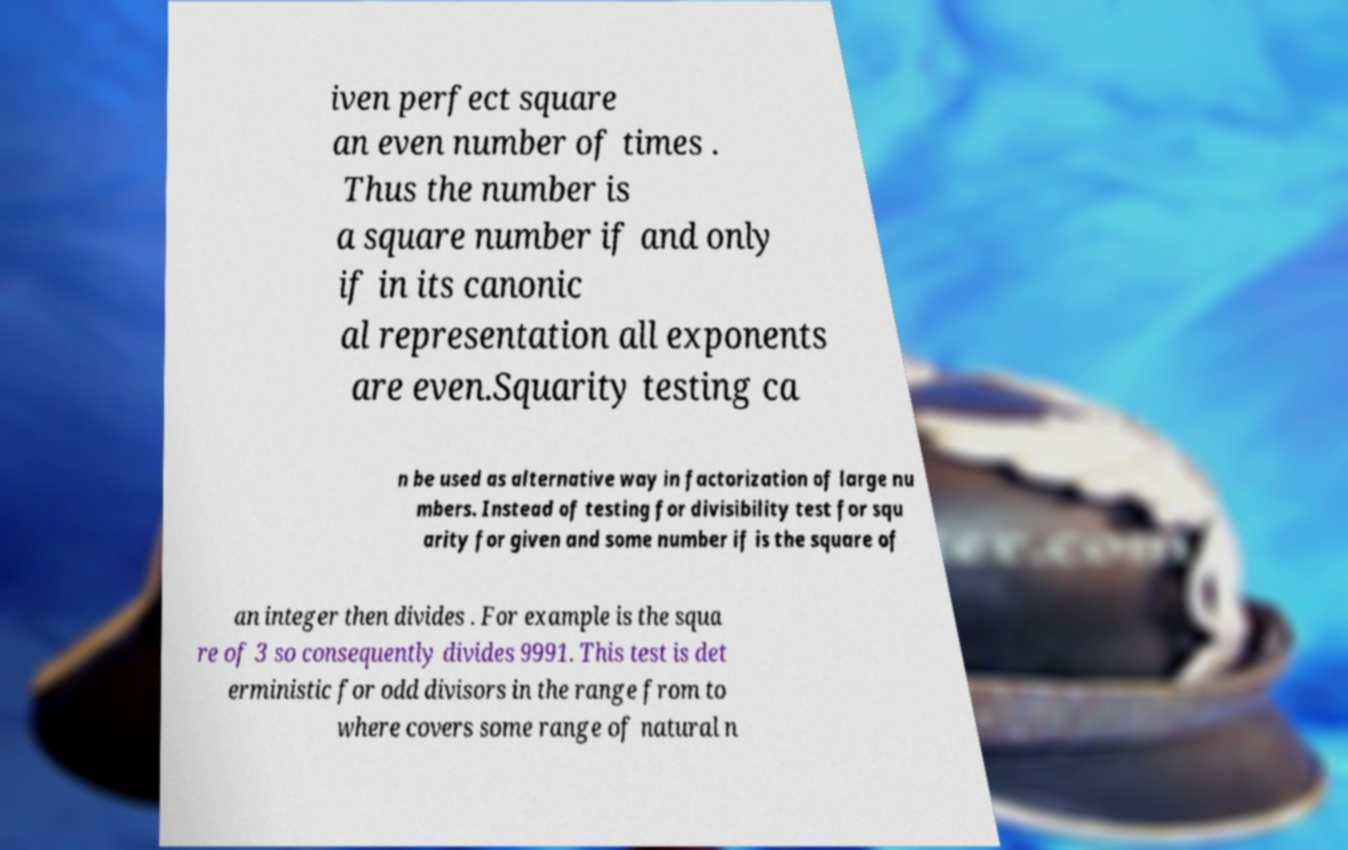Please read and relay the text visible in this image. What does it say? iven perfect square an even number of times . Thus the number is a square number if and only if in its canonic al representation all exponents are even.Squarity testing ca n be used as alternative way in factorization of large nu mbers. Instead of testing for divisibility test for squ arity for given and some number if is the square of an integer then divides . For example is the squa re of 3 so consequently divides 9991. This test is det erministic for odd divisors in the range from to where covers some range of natural n 